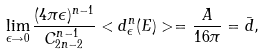Convert formula to latex. <formula><loc_0><loc_0><loc_500><loc_500>\lim _ { \epsilon \rightarrow 0 } \frac { ( 4 \pi \epsilon ) ^ { n - 1 } } { C _ { 2 n - 2 } ^ { n - 1 } } < d _ { \epsilon } ^ { n } ( E ) > = \frac { A } { 1 6 \pi } = \bar { d } ,</formula> 